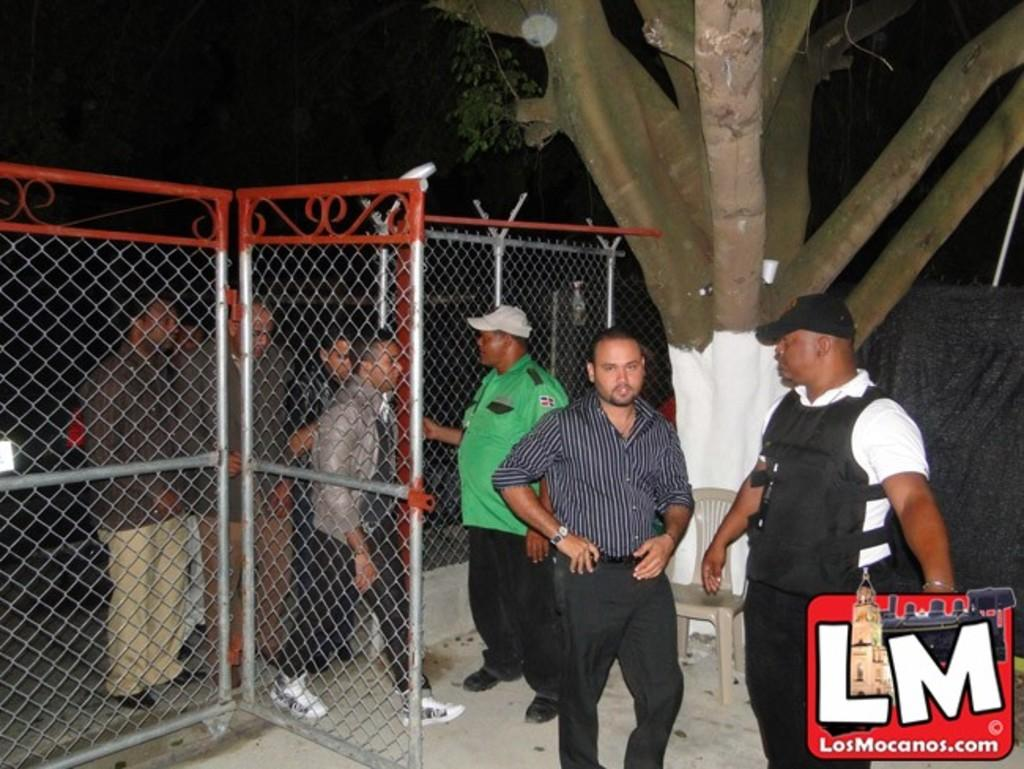What can be seen in the image involving people? There are people standing in the image. How can the people be distinguished from one another? The people are wearing different color dresses. What type of structure is present in the image? There is fencing in the image. What colors are used for the fencing? The fencing has ash and orange colors. What natural element is visible in the image? There is a tree in the image. What type of furniture is present in the image? There is a chair in the image. What type of produce is being lifted by the people in the image? There is no produce present in the image, nor are the people lifting anything. 